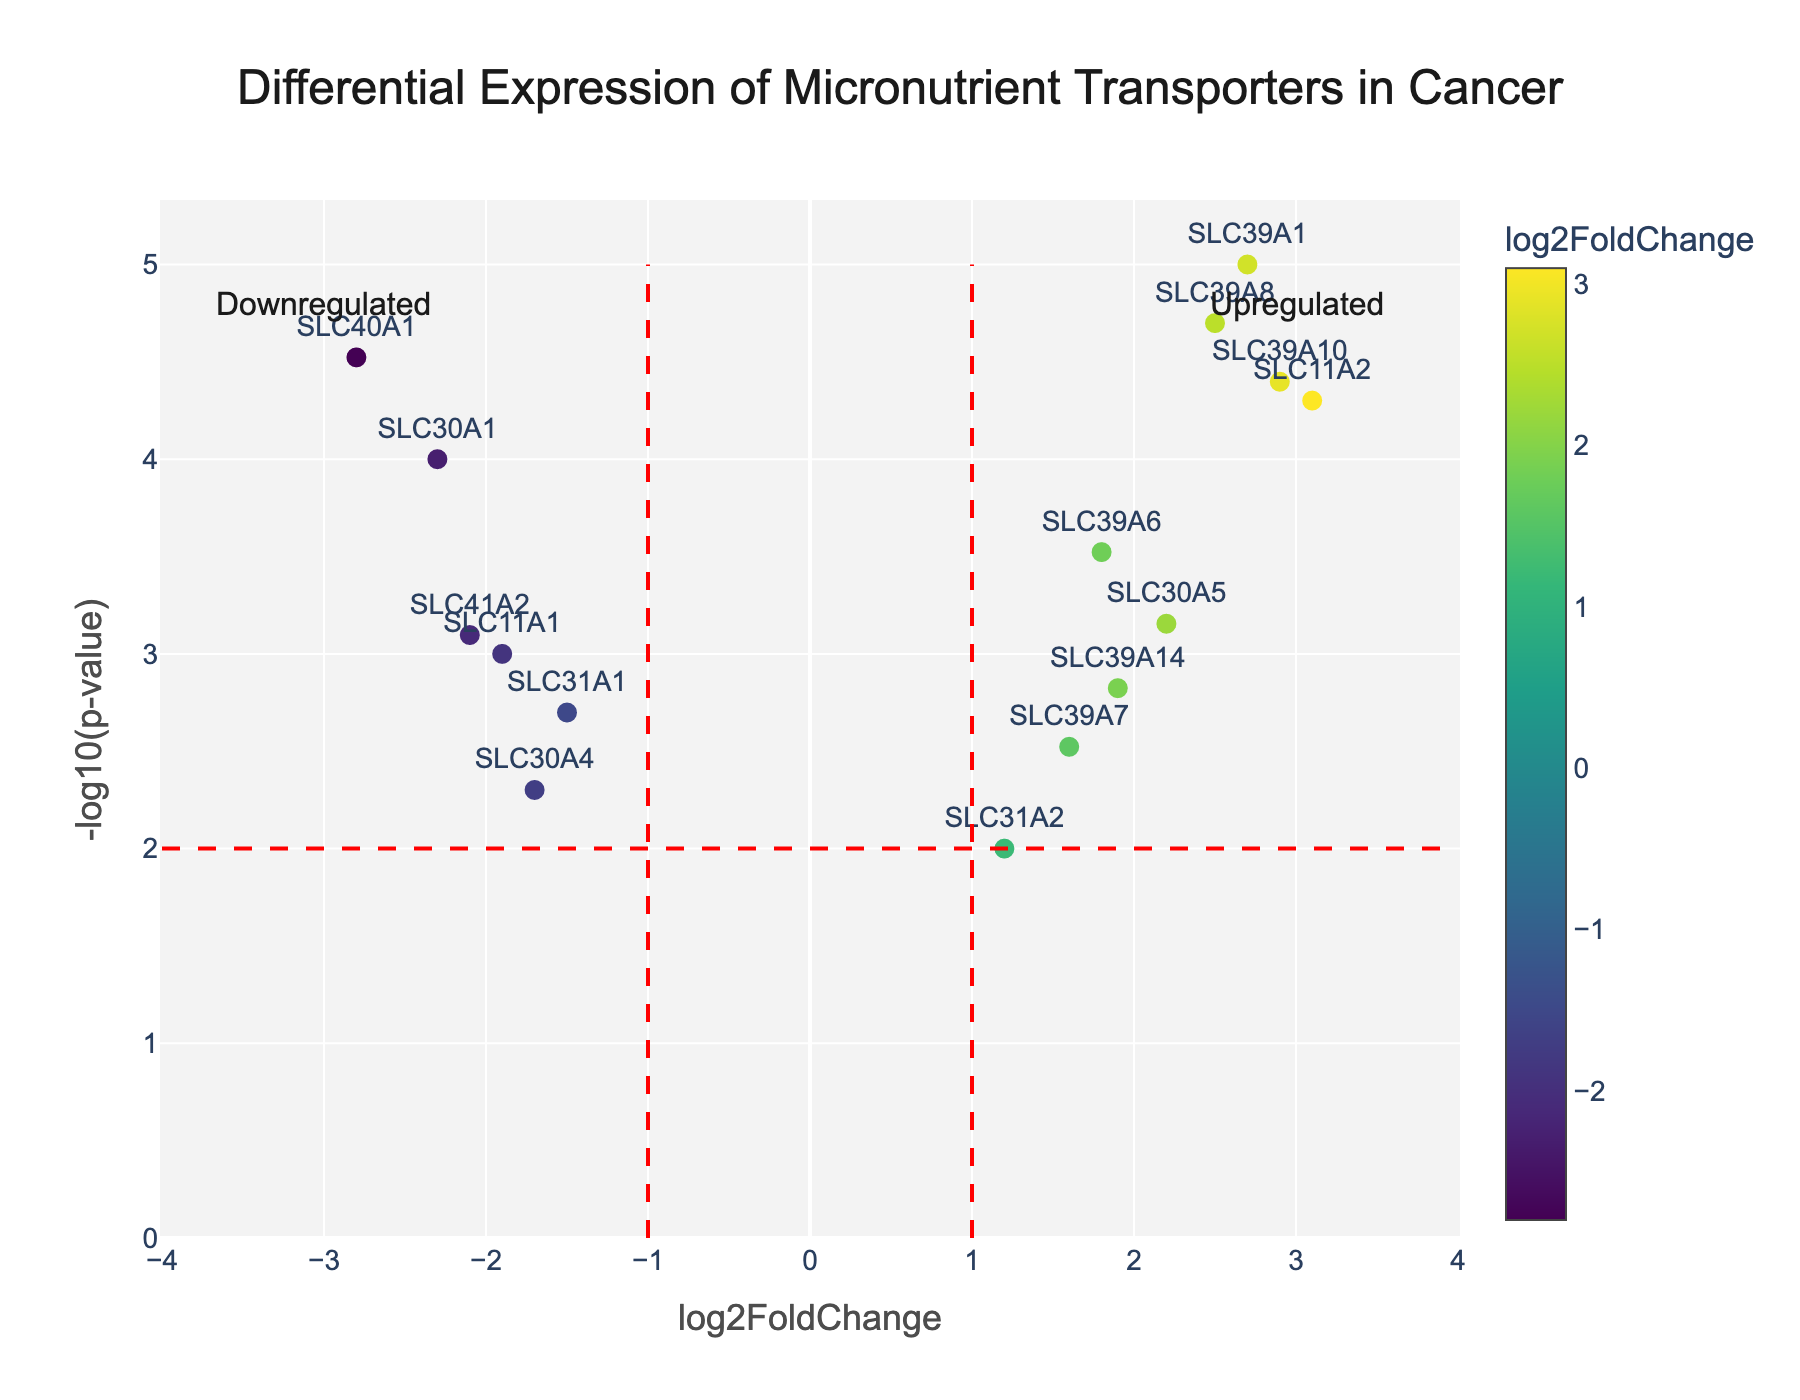Which gene has the highest log2FoldChange? By looking at the x-axis which represents log2FoldChange, identify the data point furthest to the right. The gene with the highest log2FoldChange is SLC11A2 with a log2FoldChange of 3.1.
Answer: SLC11A2 Which gene has the lowest p-value? By referring to the y-axis which represents -log10(p-value), the tallest data point on the plot has the lowest p-value. The gene with the lowest p-value is SLC39A1 with a p-value of 0.00001.
Answer: SLC39A1 How many genes are upregulated? Upregulated genes are those with positive log2FoldChange values. Count the number of points to the right of the 0 on the x-axis. The genes SLC39A6, SLC11A2, SLC39A1, SLC39A14, SLC39A8, SLC31A2, SLC39A7, SLC30A5, and SLC39A10 are upregulated, making a total of 9 genes.
Answer: 9 Which gene has the highest combined measure of log2FoldChange and statistical significance? To find the gene with the highest combined measure, look for the gene that approximates the highest values on both x and y-axes. This evaluates the log2FoldChange and -log10(p-value) together. SLC11A2 stands out with a log2FoldChange of 3.1 and a low p-value of 0.00005.
Answer: SLC11A2 What is the log2FoldChange value for SLC40A1 and its significance? Locate SLC40A1 on the plot, and check its position on the x (log2FoldChange) and y (p-value) axes. SLC40A1 has a log2FoldChange of -2.8 and a p-value of 0.00003.
Answer: -2.8, 0.00003 Which genes are significantly downregulated? Downregulated genes with a log2FoldChange < -1 and a p-value < 0.01 are of interest. Identify the genes falling to the left of the -1 line on the x-axis from the plot. The significantly downregulated genes are SLC30A1, SLC31A1, SLC41A2, SLC30A4, SLC40A1, and SLC11A1.
Answer: SLC30A1, SLC31A1, SLC41A2, SLC30A4, SLC40A1, SLC11A1 Which genes have a log2FoldChange greater than 1.5 but less than 2.5? Identify the points on the x-axis that fall between x=1.5 and x=2.5. These genes are SLC39A6, SLC39A14, SLC39A7, and SLC30A5.
Answer: SLC39A6, SLC39A14, SLC39A7, SLC30A5 What does the color scale represent in the plot, and how does it relate to the data points? The color scale on the plot represents the gradient of log2FoldChange values. Darker colors indicate higher log2FoldChange values for upregulated genes, while lighter colors indicate more neutral or downregulated genes. Points colored according to this scale provide immediate visual correlations betwen the log2FoldChange values and gene expression changes.
Answer: log2FoldChange values 